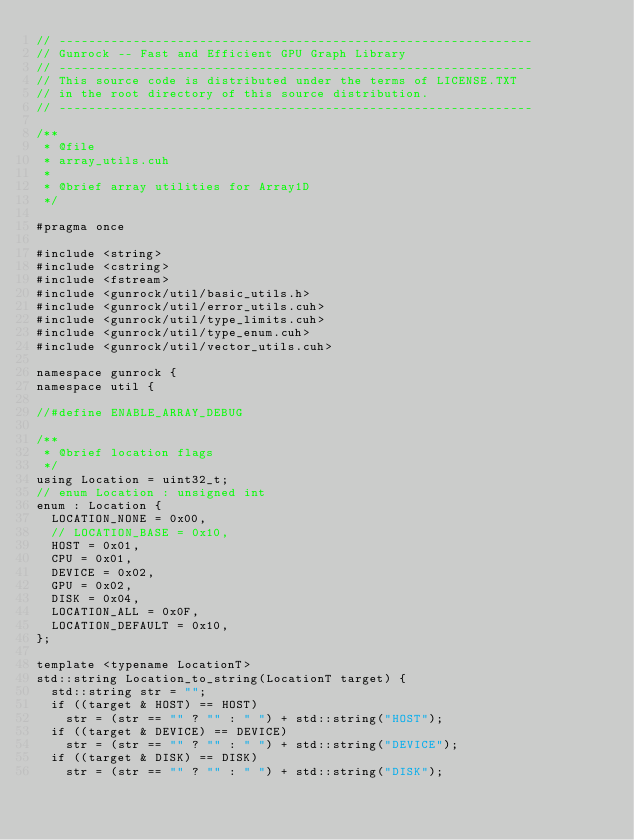Convert code to text. <code><loc_0><loc_0><loc_500><loc_500><_Cuda_>// ----------------------------------------------------------------
// Gunrock -- Fast and Efficient GPU Graph Library
// ----------------------------------------------------------------
// This source code is distributed under the terms of LICENSE.TXT
// in the root directory of this source distribution.
// ----------------------------------------------------------------

/**
 * @file
 * array_utils.cuh
 *
 * @brief array utilities for Array1D
 */

#pragma once

#include <string>
#include <cstring>
#include <fstream>
#include <gunrock/util/basic_utils.h>
#include <gunrock/util/error_utils.cuh>
#include <gunrock/util/type_limits.cuh>
#include <gunrock/util/type_enum.cuh>
#include <gunrock/util/vector_utils.cuh>

namespace gunrock {
namespace util {

//#define ENABLE_ARRAY_DEBUG

/**
 * @brief location flags
 */
using Location = uint32_t;
// enum Location : unsigned int
enum : Location {
  LOCATION_NONE = 0x00,
  // LOCATION_BASE = 0x10,
  HOST = 0x01,
  CPU = 0x01,
  DEVICE = 0x02,
  GPU = 0x02,
  DISK = 0x04,
  LOCATION_ALL = 0x0F,
  LOCATION_DEFAULT = 0x10,
};

template <typename LocationT>
std::string Location_to_string(LocationT target) {
  std::string str = "";
  if ((target & HOST) == HOST)
    str = (str == "" ? "" : " ") + std::string("HOST");
  if ((target & DEVICE) == DEVICE)
    str = (str == "" ? "" : " ") + std::string("DEVICE");
  if ((target & DISK) == DISK)
    str = (str == "" ? "" : " ") + std::string("DISK");</code> 